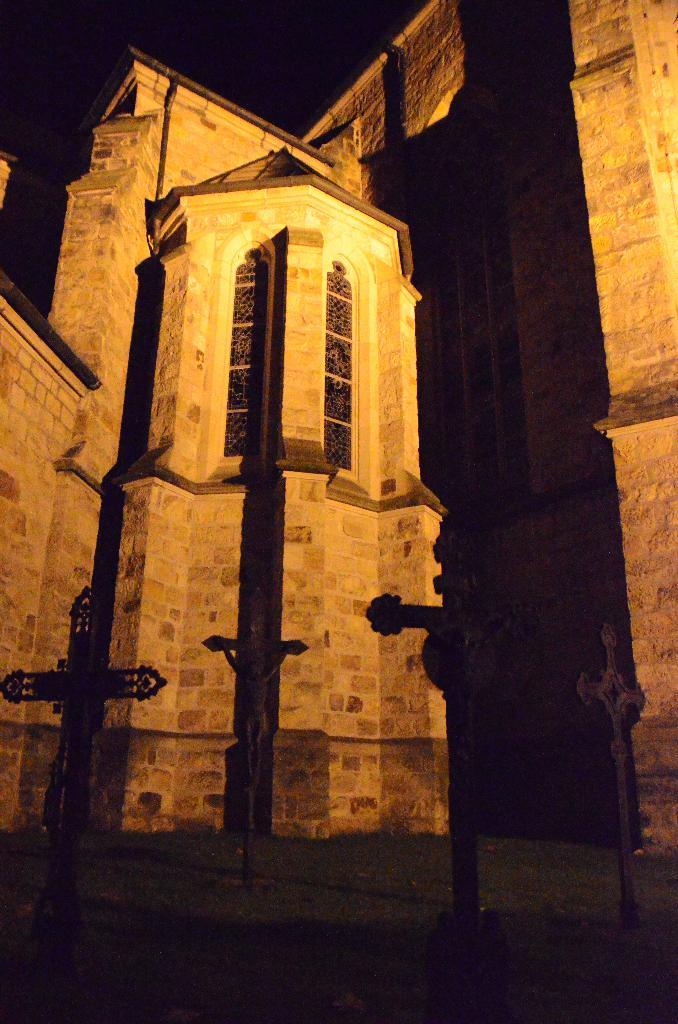What type of architecture is shown in the image? The image depicts ancient architecture. Are there any other objects or features in the image besides the architecture? Yes, there is a sculpture in the image. What is the color of the background in the image? The background of the image is dark. What type of wax can be seen dripping from the horn in the image? There is no wax or horn present in the image; it features ancient architecture and a sculpture. 